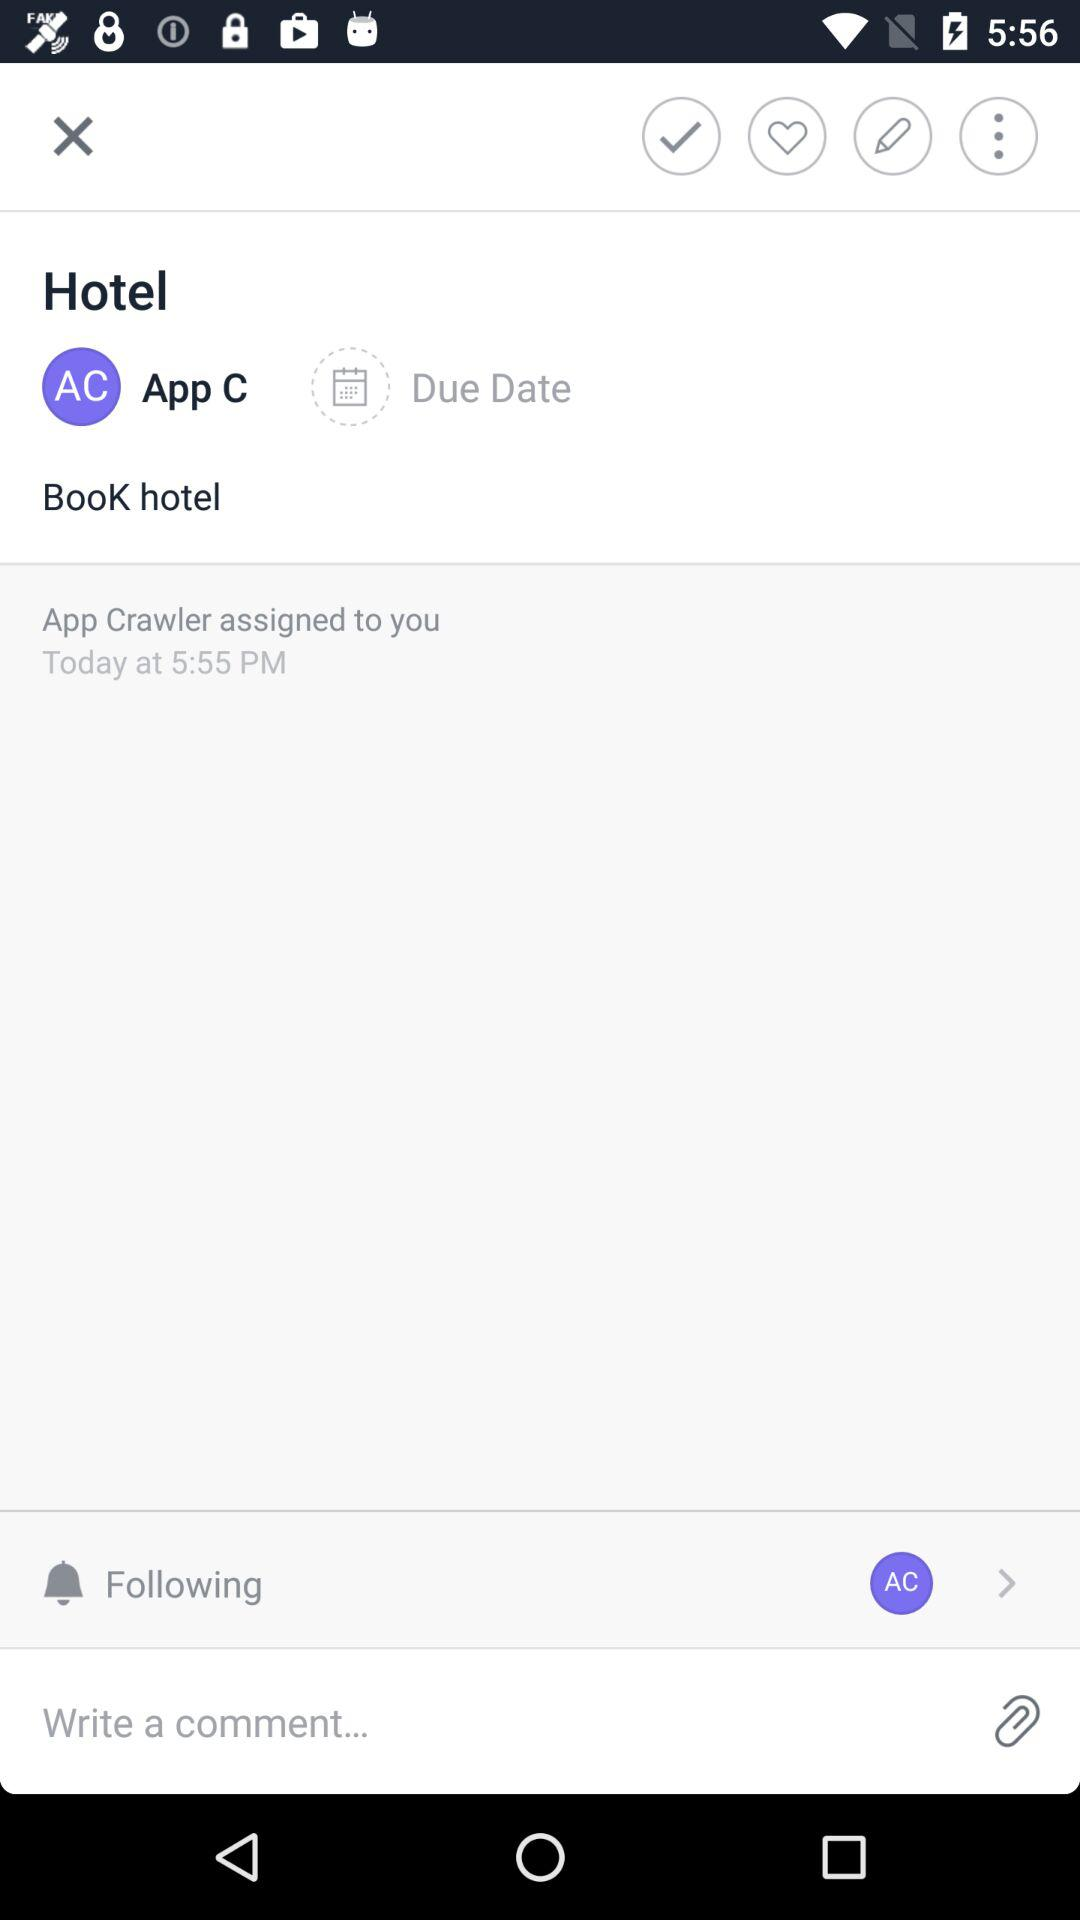What is the name of the user? The user name is App Crawler. 